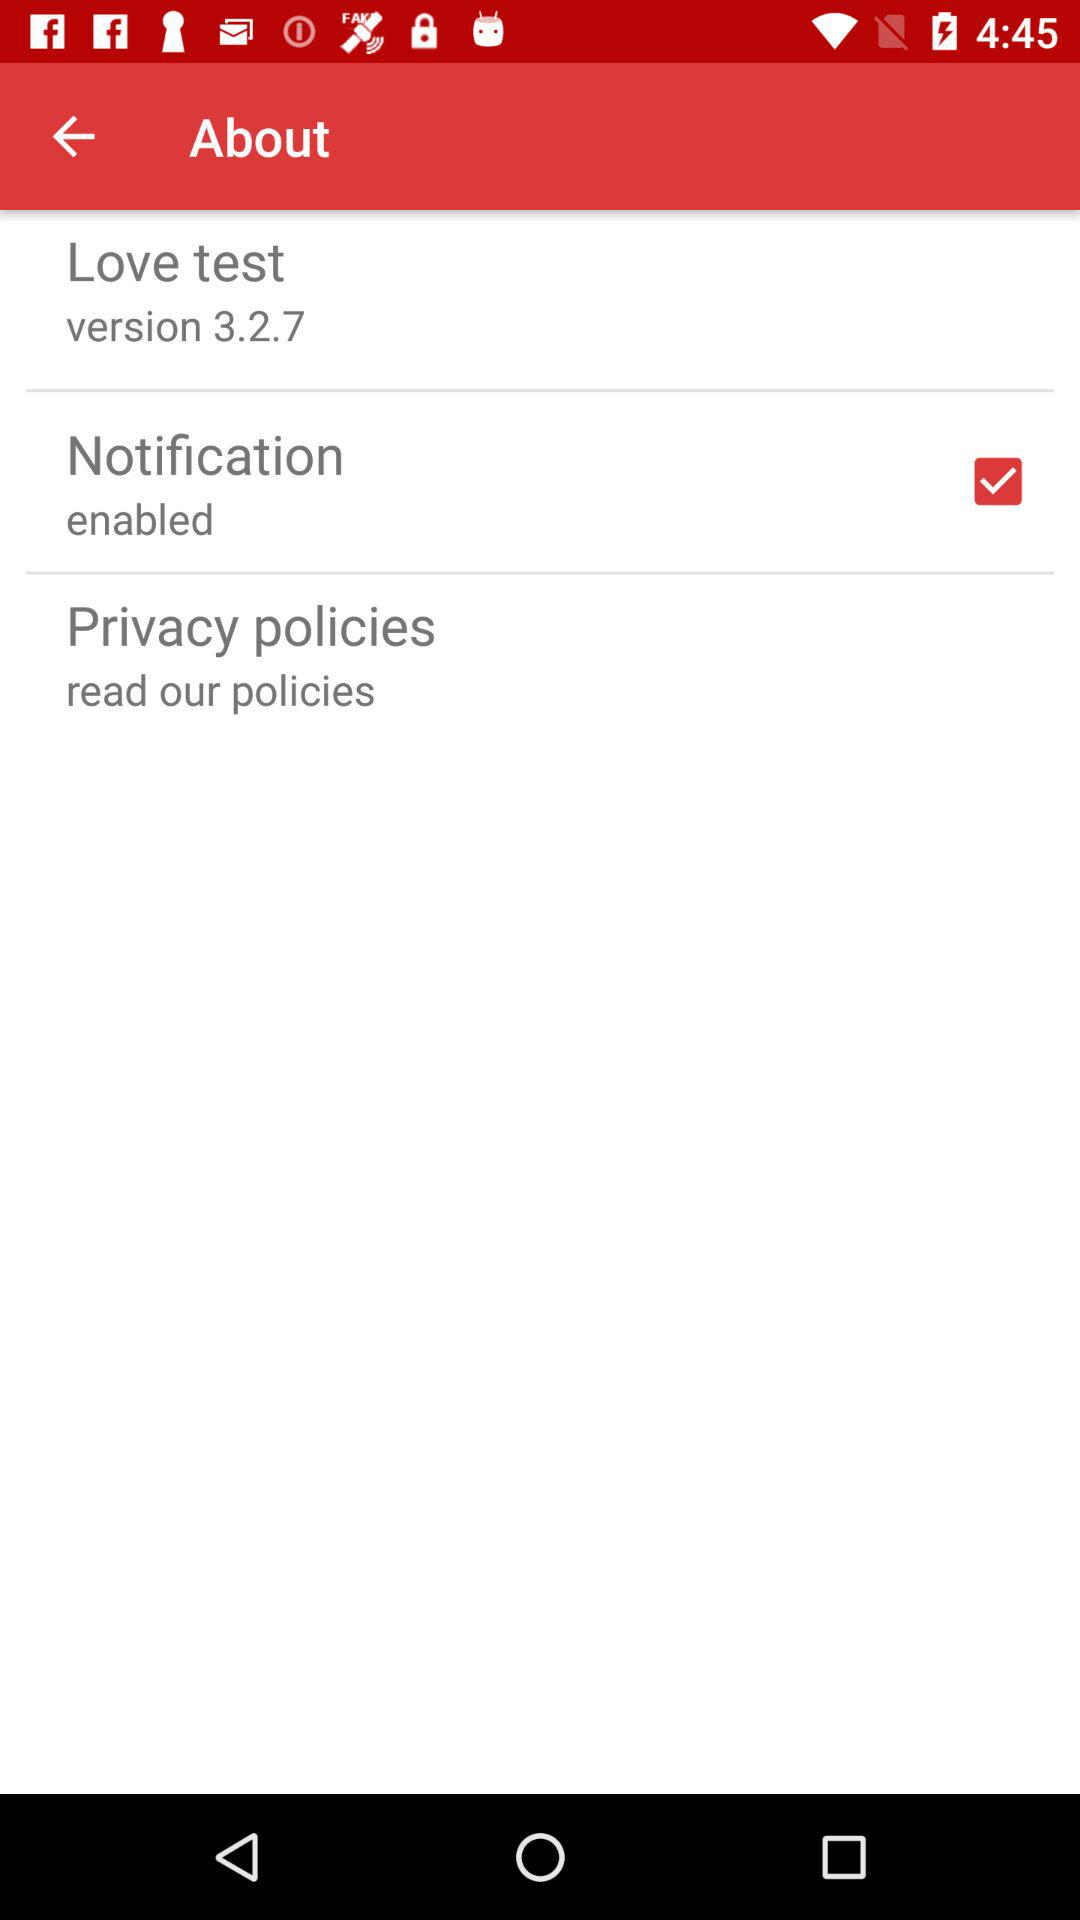What is the status of the "Notification"? The status is "on". 